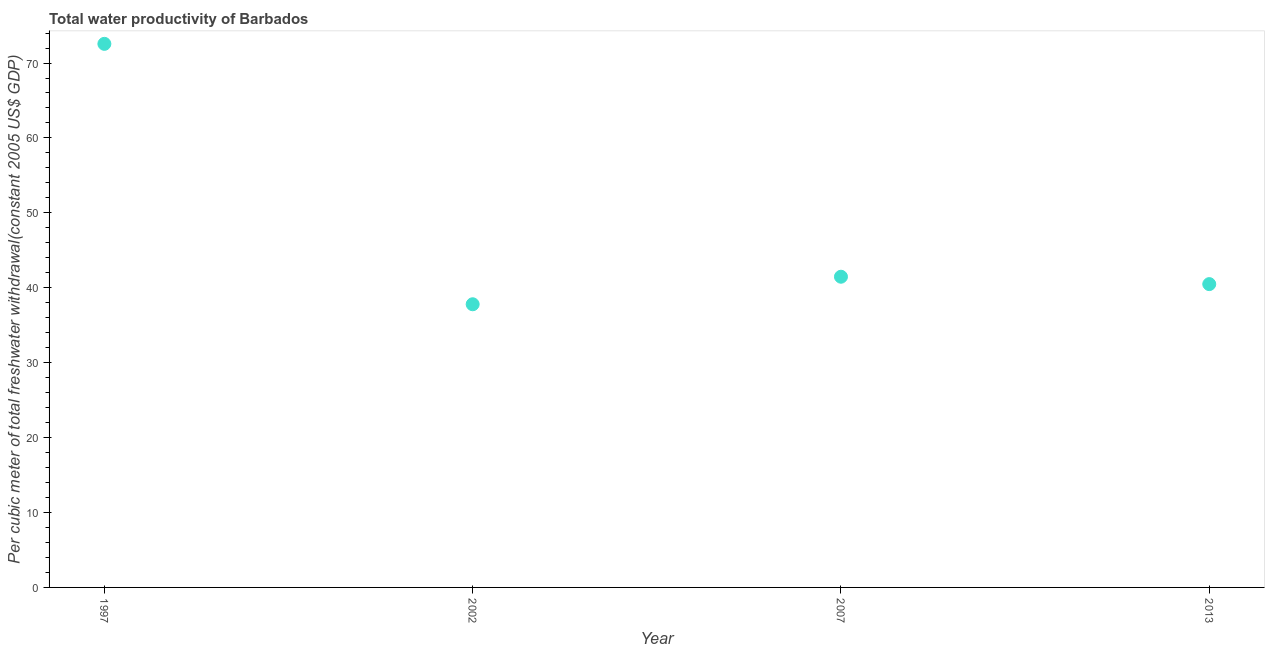What is the total water productivity in 1997?
Your response must be concise. 72.56. Across all years, what is the maximum total water productivity?
Offer a terse response. 72.56. Across all years, what is the minimum total water productivity?
Ensure brevity in your answer.  37.8. In which year was the total water productivity maximum?
Ensure brevity in your answer.  1997. In which year was the total water productivity minimum?
Ensure brevity in your answer.  2002. What is the sum of the total water productivity?
Offer a terse response. 192.32. What is the difference between the total water productivity in 2002 and 2013?
Keep it short and to the point. -2.69. What is the average total water productivity per year?
Offer a terse response. 48.08. What is the median total water productivity?
Keep it short and to the point. 40.98. In how many years, is the total water productivity greater than 68 US$?
Keep it short and to the point. 1. Do a majority of the years between 1997 and 2013 (inclusive) have total water productivity greater than 54 US$?
Offer a terse response. No. What is the ratio of the total water productivity in 2002 to that in 2013?
Offer a terse response. 0.93. Is the total water productivity in 2007 less than that in 2013?
Keep it short and to the point. No. What is the difference between the highest and the second highest total water productivity?
Provide a succinct answer. 31.09. Is the sum of the total water productivity in 2002 and 2007 greater than the maximum total water productivity across all years?
Keep it short and to the point. Yes. What is the difference between the highest and the lowest total water productivity?
Your answer should be very brief. 34.76. In how many years, is the total water productivity greater than the average total water productivity taken over all years?
Your response must be concise. 1. Does the total water productivity monotonically increase over the years?
Keep it short and to the point. No. How many years are there in the graph?
Provide a short and direct response. 4. What is the difference between two consecutive major ticks on the Y-axis?
Provide a short and direct response. 10. Are the values on the major ticks of Y-axis written in scientific E-notation?
Your answer should be very brief. No. Does the graph contain any zero values?
Ensure brevity in your answer.  No. What is the title of the graph?
Provide a succinct answer. Total water productivity of Barbados. What is the label or title of the Y-axis?
Give a very brief answer. Per cubic meter of total freshwater withdrawal(constant 2005 US$ GDP). What is the Per cubic meter of total freshwater withdrawal(constant 2005 US$ GDP) in 1997?
Keep it short and to the point. 72.56. What is the Per cubic meter of total freshwater withdrawal(constant 2005 US$ GDP) in 2002?
Your response must be concise. 37.8. What is the Per cubic meter of total freshwater withdrawal(constant 2005 US$ GDP) in 2007?
Provide a short and direct response. 41.47. What is the Per cubic meter of total freshwater withdrawal(constant 2005 US$ GDP) in 2013?
Ensure brevity in your answer.  40.49. What is the difference between the Per cubic meter of total freshwater withdrawal(constant 2005 US$ GDP) in 1997 and 2002?
Provide a short and direct response. 34.76. What is the difference between the Per cubic meter of total freshwater withdrawal(constant 2005 US$ GDP) in 1997 and 2007?
Provide a short and direct response. 31.09. What is the difference between the Per cubic meter of total freshwater withdrawal(constant 2005 US$ GDP) in 1997 and 2013?
Your answer should be very brief. 32.07. What is the difference between the Per cubic meter of total freshwater withdrawal(constant 2005 US$ GDP) in 2002 and 2007?
Provide a succinct answer. -3.68. What is the difference between the Per cubic meter of total freshwater withdrawal(constant 2005 US$ GDP) in 2002 and 2013?
Your answer should be very brief. -2.69. What is the difference between the Per cubic meter of total freshwater withdrawal(constant 2005 US$ GDP) in 2007 and 2013?
Keep it short and to the point. 0.99. What is the ratio of the Per cubic meter of total freshwater withdrawal(constant 2005 US$ GDP) in 1997 to that in 2002?
Your answer should be very brief. 1.92. What is the ratio of the Per cubic meter of total freshwater withdrawal(constant 2005 US$ GDP) in 1997 to that in 2013?
Give a very brief answer. 1.79. What is the ratio of the Per cubic meter of total freshwater withdrawal(constant 2005 US$ GDP) in 2002 to that in 2007?
Provide a succinct answer. 0.91. What is the ratio of the Per cubic meter of total freshwater withdrawal(constant 2005 US$ GDP) in 2002 to that in 2013?
Your response must be concise. 0.93. 